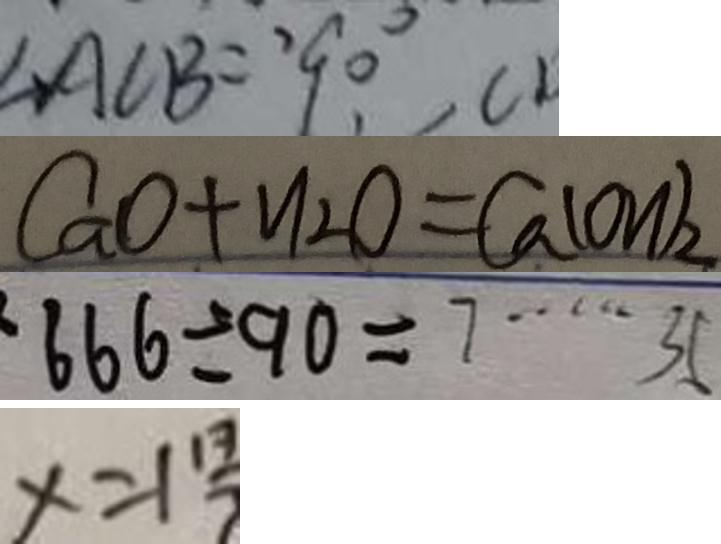<formula> <loc_0><loc_0><loc_500><loc_500>\angle A C B = 9 0 ^ { \circ } 
 C a O + H _ { 2 } O = C a ( O H ) _ { 2 } 
 6 6 6 \div 9 0 = 7 \cdots 3 5 
 x = 1 \frac { 1 3 } { 7 }</formula> 